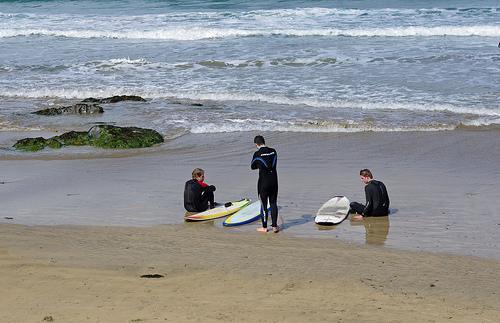How many men are there?
Give a very brief answer. 3. 